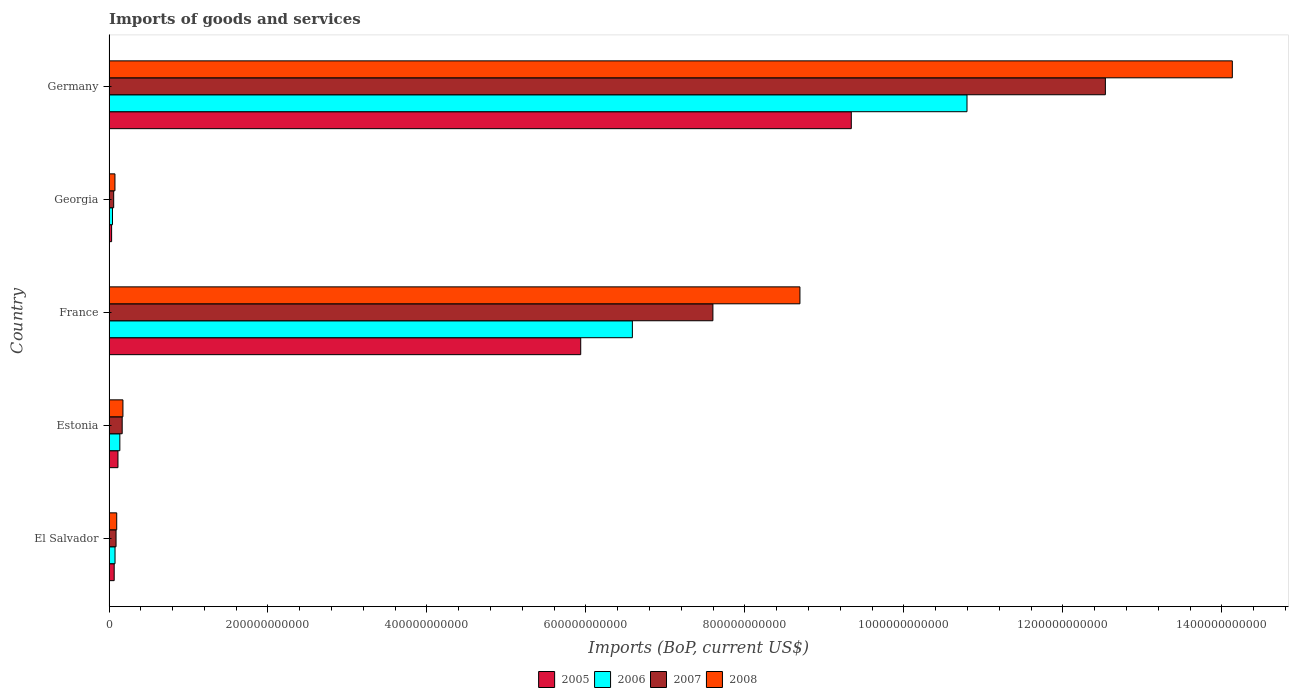How many different coloured bars are there?
Provide a succinct answer. 4. How many groups of bars are there?
Provide a short and direct response. 5. How many bars are there on the 4th tick from the top?
Offer a very short reply. 4. What is the label of the 4th group of bars from the top?
Offer a very short reply. Estonia. What is the amount spent on imports in 2005 in El Salvador?
Provide a short and direct response. 6.51e+09. Across all countries, what is the maximum amount spent on imports in 2008?
Offer a terse response. 1.41e+12. Across all countries, what is the minimum amount spent on imports in 2008?
Provide a succinct answer. 7.47e+09. In which country was the amount spent on imports in 2007 maximum?
Provide a short and direct response. Germany. In which country was the amount spent on imports in 2007 minimum?
Your answer should be compact. Georgia. What is the total amount spent on imports in 2006 in the graph?
Your answer should be compact. 1.76e+12. What is the difference between the amount spent on imports in 2007 in France and that in Germany?
Your answer should be very brief. -4.94e+11. What is the difference between the amount spent on imports in 2007 in Germany and the amount spent on imports in 2008 in Estonia?
Your answer should be compact. 1.24e+12. What is the average amount spent on imports in 2007 per country?
Your response must be concise. 4.09e+11. What is the difference between the amount spent on imports in 2008 and amount spent on imports in 2005 in Estonia?
Offer a terse response. 6.27e+09. In how many countries, is the amount spent on imports in 2006 greater than 360000000000 US$?
Give a very brief answer. 2. What is the ratio of the amount spent on imports in 2006 in El Salvador to that in Germany?
Give a very brief answer. 0.01. Is the amount spent on imports in 2008 in Georgia less than that in Germany?
Make the answer very short. Yes. Is the difference between the amount spent on imports in 2008 in El Salvador and Georgia greater than the difference between the amount spent on imports in 2005 in El Salvador and Georgia?
Provide a short and direct response. No. What is the difference between the highest and the second highest amount spent on imports in 2005?
Provide a succinct answer. 3.40e+11. What is the difference between the highest and the lowest amount spent on imports in 2007?
Give a very brief answer. 1.25e+12. Is the sum of the amount spent on imports in 2005 in El Salvador and Estonia greater than the maximum amount spent on imports in 2008 across all countries?
Give a very brief answer. No. Is it the case that in every country, the sum of the amount spent on imports in 2005 and amount spent on imports in 2007 is greater than the sum of amount spent on imports in 2008 and amount spent on imports in 2006?
Provide a succinct answer. No. Is it the case that in every country, the sum of the amount spent on imports in 2006 and amount spent on imports in 2005 is greater than the amount spent on imports in 2008?
Your answer should be compact. Yes. Are all the bars in the graph horizontal?
Make the answer very short. Yes. What is the difference between two consecutive major ticks on the X-axis?
Your answer should be compact. 2.00e+11. Does the graph contain any zero values?
Keep it short and to the point. No. How are the legend labels stacked?
Ensure brevity in your answer.  Horizontal. What is the title of the graph?
Give a very brief answer. Imports of goods and services. Does "1996" appear as one of the legend labels in the graph?
Your answer should be very brief. No. What is the label or title of the X-axis?
Make the answer very short. Imports (BoP, current US$). What is the label or title of the Y-axis?
Your response must be concise. Country. What is the Imports (BoP, current US$) in 2005 in El Salvador?
Keep it short and to the point. 6.51e+09. What is the Imports (BoP, current US$) in 2006 in El Salvador?
Offer a very short reply. 7.57e+09. What is the Imports (BoP, current US$) in 2007 in El Salvador?
Give a very brief answer. 8.86e+09. What is the Imports (BoP, current US$) of 2008 in El Salvador?
Your response must be concise. 9.70e+09. What is the Imports (BoP, current US$) in 2005 in Estonia?
Your response must be concise. 1.12e+1. What is the Imports (BoP, current US$) in 2006 in Estonia?
Make the answer very short. 1.36e+1. What is the Imports (BoP, current US$) of 2007 in Estonia?
Make the answer very short. 1.66e+1. What is the Imports (BoP, current US$) of 2008 in Estonia?
Provide a short and direct response. 1.75e+1. What is the Imports (BoP, current US$) of 2005 in France?
Provide a short and direct response. 5.93e+11. What is the Imports (BoP, current US$) of 2006 in France?
Your answer should be compact. 6.58e+11. What is the Imports (BoP, current US$) of 2007 in France?
Provide a succinct answer. 7.60e+11. What is the Imports (BoP, current US$) of 2008 in France?
Your answer should be compact. 8.69e+11. What is the Imports (BoP, current US$) in 2005 in Georgia?
Give a very brief answer. 3.27e+09. What is the Imports (BoP, current US$) in 2006 in Georgia?
Provide a succinct answer. 4.38e+09. What is the Imports (BoP, current US$) of 2007 in Georgia?
Make the answer very short. 5.88e+09. What is the Imports (BoP, current US$) of 2008 in Georgia?
Offer a very short reply. 7.47e+09. What is the Imports (BoP, current US$) of 2005 in Germany?
Ensure brevity in your answer.  9.34e+11. What is the Imports (BoP, current US$) in 2006 in Germany?
Provide a succinct answer. 1.08e+12. What is the Imports (BoP, current US$) in 2007 in Germany?
Keep it short and to the point. 1.25e+12. What is the Imports (BoP, current US$) of 2008 in Germany?
Give a very brief answer. 1.41e+12. Across all countries, what is the maximum Imports (BoP, current US$) of 2005?
Keep it short and to the point. 9.34e+11. Across all countries, what is the maximum Imports (BoP, current US$) of 2006?
Provide a succinct answer. 1.08e+12. Across all countries, what is the maximum Imports (BoP, current US$) in 2007?
Offer a terse response. 1.25e+12. Across all countries, what is the maximum Imports (BoP, current US$) in 2008?
Provide a succinct answer. 1.41e+12. Across all countries, what is the minimum Imports (BoP, current US$) in 2005?
Provide a short and direct response. 3.27e+09. Across all countries, what is the minimum Imports (BoP, current US$) in 2006?
Offer a terse response. 4.38e+09. Across all countries, what is the minimum Imports (BoP, current US$) in 2007?
Give a very brief answer. 5.88e+09. Across all countries, what is the minimum Imports (BoP, current US$) in 2008?
Ensure brevity in your answer.  7.47e+09. What is the total Imports (BoP, current US$) in 2005 in the graph?
Provide a succinct answer. 1.55e+12. What is the total Imports (BoP, current US$) in 2006 in the graph?
Offer a very short reply. 1.76e+12. What is the total Imports (BoP, current US$) in 2007 in the graph?
Make the answer very short. 2.04e+12. What is the total Imports (BoP, current US$) of 2008 in the graph?
Offer a very short reply. 2.32e+12. What is the difference between the Imports (BoP, current US$) of 2005 in El Salvador and that in Estonia?
Your answer should be very brief. -4.74e+09. What is the difference between the Imports (BoP, current US$) in 2006 in El Salvador and that in Estonia?
Make the answer very short. -6.05e+09. What is the difference between the Imports (BoP, current US$) of 2007 in El Salvador and that in Estonia?
Provide a short and direct response. -7.72e+09. What is the difference between the Imports (BoP, current US$) of 2008 in El Salvador and that in Estonia?
Your response must be concise. -7.81e+09. What is the difference between the Imports (BoP, current US$) of 2005 in El Salvador and that in France?
Keep it short and to the point. -5.87e+11. What is the difference between the Imports (BoP, current US$) of 2006 in El Salvador and that in France?
Your answer should be compact. -6.51e+11. What is the difference between the Imports (BoP, current US$) of 2007 in El Salvador and that in France?
Your answer should be compact. -7.51e+11. What is the difference between the Imports (BoP, current US$) of 2008 in El Salvador and that in France?
Offer a terse response. -8.60e+11. What is the difference between the Imports (BoP, current US$) of 2005 in El Salvador and that in Georgia?
Offer a terse response. 3.24e+09. What is the difference between the Imports (BoP, current US$) of 2006 in El Salvador and that in Georgia?
Your response must be concise. 3.19e+09. What is the difference between the Imports (BoP, current US$) of 2007 in El Salvador and that in Georgia?
Offer a terse response. 2.98e+09. What is the difference between the Imports (BoP, current US$) in 2008 in El Salvador and that in Georgia?
Your answer should be compact. 2.23e+09. What is the difference between the Imports (BoP, current US$) in 2005 in El Salvador and that in Germany?
Keep it short and to the point. -9.27e+11. What is the difference between the Imports (BoP, current US$) of 2006 in El Salvador and that in Germany?
Provide a succinct answer. -1.07e+12. What is the difference between the Imports (BoP, current US$) of 2007 in El Salvador and that in Germany?
Keep it short and to the point. -1.24e+12. What is the difference between the Imports (BoP, current US$) in 2008 in El Salvador and that in Germany?
Keep it short and to the point. -1.40e+12. What is the difference between the Imports (BoP, current US$) in 2005 in Estonia and that in France?
Your answer should be compact. -5.82e+11. What is the difference between the Imports (BoP, current US$) of 2006 in Estonia and that in France?
Ensure brevity in your answer.  -6.45e+11. What is the difference between the Imports (BoP, current US$) of 2007 in Estonia and that in France?
Make the answer very short. -7.43e+11. What is the difference between the Imports (BoP, current US$) in 2008 in Estonia and that in France?
Make the answer very short. -8.52e+11. What is the difference between the Imports (BoP, current US$) in 2005 in Estonia and that in Georgia?
Ensure brevity in your answer.  7.98e+09. What is the difference between the Imports (BoP, current US$) of 2006 in Estonia and that in Georgia?
Offer a very short reply. 9.24e+09. What is the difference between the Imports (BoP, current US$) of 2007 in Estonia and that in Georgia?
Offer a terse response. 1.07e+1. What is the difference between the Imports (BoP, current US$) in 2008 in Estonia and that in Georgia?
Your answer should be compact. 1.00e+1. What is the difference between the Imports (BoP, current US$) of 2005 in Estonia and that in Germany?
Keep it short and to the point. -9.23e+11. What is the difference between the Imports (BoP, current US$) of 2006 in Estonia and that in Germany?
Offer a terse response. -1.07e+12. What is the difference between the Imports (BoP, current US$) in 2007 in Estonia and that in Germany?
Provide a succinct answer. -1.24e+12. What is the difference between the Imports (BoP, current US$) of 2008 in Estonia and that in Germany?
Your response must be concise. -1.40e+12. What is the difference between the Imports (BoP, current US$) of 2005 in France and that in Georgia?
Make the answer very short. 5.90e+11. What is the difference between the Imports (BoP, current US$) in 2006 in France and that in Georgia?
Provide a short and direct response. 6.54e+11. What is the difference between the Imports (BoP, current US$) of 2007 in France and that in Georgia?
Keep it short and to the point. 7.54e+11. What is the difference between the Imports (BoP, current US$) of 2008 in France and that in Georgia?
Keep it short and to the point. 8.62e+11. What is the difference between the Imports (BoP, current US$) of 2005 in France and that in Germany?
Your answer should be compact. -3.40e+11. What is the difference between the Imports (BoP, current US$) of 2006 in France and that in Germany?
Give a very brief answer. -4.21e+11. What is the difference between the Imports (BoP, current US$) in 2007 in France and that in Germany?
Your answer should be compact. -4.94e+11. What is the difference between the Imports (BoP, current US$) in 2008 in France and that in Germany?
Make the answer very short. -5.44e+11. What is the difference between the Imports (BoP, current US$) of 2005 in Georgia and that in Germany?
Offer a very short reply. -9.31e+11. What is the difference between the Imports (BoP, current US$) of 2006 in Georgia and that in Germany?
Your answer should be compact. -1.08e+12. What is the difference between the Imports (BoP, current US$) of 2007 in Georgia and that in Germany?
Offer a terse response. -1.25e+12. What is the difference between the Imports (BoP, current US$) in 2008 in Georgia and that in Germany?
Provide a succinct answer. -1.41e+12. What is the difference between the Imports (BoP, current US$) of 2005 in El Salvador and the Imports (BoP, current US$) of 2006 in Estonia?
Your answer should be very brief. -7.11e+09. What is the difference between the Imports (BoP, current US$) of 2005 in El Salvador and the Imports (BoP, current US$) of 2007 in Estonia?
Make the answer very short. -1.01e+1. What is the difference between the Imports (BoP, current US$) in 2005 in El Salvador and the Imports (BoP, current US$) in 2008 in Estonia?
Your answer should be compact. -1.10e+1. What is the difference between the Imports (BoP, current US$) of 2006 in El Salvador and the Imports (BoP, current US$) of 2007 in Estonia?
Give a very brief answer. -9.00e+09. What is the difference between the Imports (BoP, current US$) of 2006 in El Salvador and the Imports (BoP, current US$) of 2008 in Estonia?
Your answer should be compact. -9.94e+09. What is the difference between the Imports (BoP, current US$) of 2007 in El Salvador and the Imports (BoP, current US$) of 2008 in Estonia?
Offer a very short reply. -8.66e+09. What is the difference between the Imports (BoP, current US$) in 2005 in El Salvador and the Imports (BoP, current US$) in 2006 in France?
Your answer should be compact. -6.52e+11. What is the difference between the Imports (BoP, current US$) in 2005 in El Salvador and the Imports (BoP, current US$) in 2007 in France?
Your answer should be very brief. -7.53e+11. What is the difference between the Imports (BoP, current US$) of 2005 in El Salvador and the Imports (BoP, current US$) of 2008 in France?
Ensure brevity in your answer.  -8.63e+11. What is the difference between the Imports (BoP, current US$) of 2006 in El Salvador and the Imports (BoP, current US$) of 2007 in France?
Provide a short and direct response. -7.52e+11. What is the difference between the Imports (BoP, current US$) in 2006 in El Salvador and the Imports (BoP, current US$) in 2008 in France?
Your response must be concise. -8.62e+11. What is the difference between the Imports (BoP, current US$) of 2007 in El Salvador and the Imports (BoP, current US$) of 2008 in France?
Your answer should be very brief. -8.60e+11. What is the difference between the Imports (BoP, current US$) of 2005 in El Salvador and the Imports (BoP, current US$) of 2006 in Georgia?
Ensure brevity in your answer.  2.13e+09. What is the difference between the Imports (BoP, current US$) of 2005 in El Salvador and the Imports (BoP, current US$) of 2007 in Georgia?
Provide a short and direct response. 6.29e+08. What is the difference between the Imports (BoP, current US$) in 2005 in El Salvador and the Imports (BoP, current US$) in 2008 in Georgia?
Provide a succinct answer. -9.62e+08. What is the difference between the Imports (BoP, current US$) in 2006 in El Salvador and the Imports (BoP, current US$) in 2007 in Georgia?
Provide a succinct answer. 1.69e+09. What is the difference between the Imports (BoP, current US$) of 2006 in El Salvador and the Imports (BoP, current US$) of 2008 in Georgia?
Keep it short and to the point. 1.00e+08. What is the difference between the Imports (BoP, current US$) in 2007 in El Salvador and the Imports (BoP, current US$) in 2008 in Georgia?
Offer a very short reply. 1.38e+09. What is the difference between the Imports (BoP, current US$) of 2005 in El Salvador and the Imports (BoP, current US$) of 2006 in Germany?
Provide a succinct answer. -1.07e+12. What is the difference between the Imports (BoP, current US$) of 2005 in El Salvador and the Imports (BoP, current US$) of 2007 in Germany?
Your answer should be very brief. -1.25e+12. What is the difference between the Imports (BoP, current US$) of 2005 in El Salvador and the Imports (BoP, current US$) of 2008 in Germany?
Provide a short and direct response. -1.41e+12. What is the difference between the Imports (BoP, current US$) of 2006 in El Salvador and the Imports (BoP, current US$) of 2007 in Germany?
Your answer should be very brief. -1.25e+12. What is the difference between the Imports (BoP, current US$) in 2006 in El Salvador and the Imports (BoP, current US$) in 2008 in Germany?
Make the answer very short. -1.41e+12. What is the difference between the Imports (BoP, current US$) in 2007 in El Salvador and the Imports (BoP, current US$) in 2008 in Germany?
Offer a terse response. -1.40e+12. What is the difference between the Imports (BoP, current US$) of 2005 in Estonia and the Imports (BoP, current US$) of 2006 in France?
Ensure brevity in your answer.  -6.47e+11. What is the difference between the Imports (BoP, current US$) of 2005 in Estonia and the Imports (BoP, current US$) of 2007 in France?
Your response must be concise. -7.48e+11. What is the difference between the Imports (BoP, current US$) of 2005 in Estonia and the Imports (BoP, current US$) of 2008 in France?
Make the answer very short. -8.58e+11. What is the difference between the Imports (BoP, current US$) of 2006 in Estonia and the Imports (BoP, current US$) of 2007 in France?
Ensure brevity in your answer.  -7.46e+11. What is the difference between the Imports (BoP, current US$) in 2006 in Estonia and the Imports (BoP, current US$) in 2008 in France?
Offer a very short reply. -8.56e+11. What is the difference between the Imports (BoP, current US$) in 2007 in Estonia and the Imports (BoP, current US$) in 2008 in France?
Your answer should be very brief. -8.53e+11. What is the difference between the Imports (BoP, current US$) of 2005 in Estonia and the Imports (BoP, current US$) of 2006 in Georgia?
Offer a terse response. 6.87e+09. What is the difference between the Imports (BoP, current US$) in 2005 in Estonia and the Imports (BoP, current US$) in 2007 in Georgia?
Keep it short and to the point. 5.37e+09. What is the difference between the Imports (BoP, current US$) of 2005 in Estonia and the Imports (BoP, current US$) of 2008 in Georgia?
Offer a terse response. 3.78e+09. What is the difference between the Imports (BoP, current US$) of 2006 in Estonia and the Imports (BoP, current US$) of 2007 in Georgia?
Give a very brief answer. 7.74e+09. What is the difference between the Imports (BoP, current US$) in 2006 in Estonia and the Imports (BoP, current US$) in 2008 in Georgia?
Ensure brevity in your answer.  6.15e+09. What is the difference between the Imports (BoP, current US$) in 2007 in Estonia and the Imports (BoP, current US$) in 2008 in Georgia?
Ensure brevity in your answer.  9.10e+09. What is the difference between the Imports (BoP, current US$) of 2005 in Estonia and the Imports (BoP, current US$) of 2006 in Germany?
Provide a succinct answer. -1.07e+12. What is the difference between the Imports (BoP, current US$) of 2005 in Estonia and the Imports (BoP, current US$) of 2007 in Germany?
Offer a terse response. -1.24e+12. What is the difference between the Imports (BoP, current US$) of 2005 in Estonia and the Imports (BoP, current US$) of 2008 in Germany?
Give a very brief answer. -1.40e+12. What is the difference between the Imports (BoP, current US$) in 2006 in Estonia and the Imports (BoP, current US$) in 2007 in Germany?
Your answer should be very brief. -1.24e+12. What is the difference between the Imports (BoP, current US$) of 2006 in Estonia and the Imports (BoP, current US$) of 2008 in Germany?
Your response must be concise. -1.40e+12. What is the difference between the Imports (BoP, current US$) of 2007 in Estonia and the Imports (BoP, current US$) of 2008 in Germany?
Ensure brevity in your answer.  -1.40e+12. What is the difference between the Imports (BoP, current US$) in 2005 in France and the Imports (BoP, current US$) in 2006 in Georgia?
Give a very brief answer. 5.89e+11. What is the difference between the Imports (BoP, current US$) of 2005 in France and the Imports (BoP, current US$) of 2007 in Georgia?
Ensure brevity in your answer.  5.88e+11. What is the difference between the Imports (BoP, current US$) in 2005 in France and the Imports (BoP, current US$) in 2008 in Georgia?
Ensure brevity in your answer.  5.86e+11. What is the difference between the Imports (BoP, current US$) in 2006 in France and the Imports (BoP, current US$) in 2007 in Georgia?
Your answer should be compact. 6.53e+11. What is the difference between the Imports (BoP, current US$) of 2006 in France and the Imports (BoP, current US$) of 2008 in Georgia?
Your response must be concise. 6.51e+11. What is the difference between the Imports (BoP, current US$) of 2007 in France and the Imports (BoP, current US$) of 2008 in Georgia?
Your response must be concise. 7.52e+11. What is the difference between the Imports (BoP, current US$) of 2005 in France and the Imports (BoP, current US$) of 2006 in Germany?
Keep it short and to the point. -4.86e+11. What is the difference between the Imports (BoP, current US$) of 2005 in France and the Imports (BoP, current US$) of 2007 in Germany?
Provide a succinct answer. -6.60e+11. What is the difference between the Imports (BoP, current US$) in 2005 in France and the Imports (BoP, current US$) in 2008 in Germany?
Provide a short and direct response. -8.20e+11. What is the difference between the Imports (BoP, current US$) in 2006 in France and the Imports (BoP, current US$) in 2007 in Germany?
Your answer should be compact. -5.95e+11. What is the difference between the Imports (BoP, current US$) in 2006 in France and the Imports (BoP, current US$) in 2008 in Germany?
Your response must be concise. -7.55e+11. What is the difference between the Imports (BoP, current US$) of 2007 in France and the Imports (BoP, current US$) of 2008 in Germany?
Your answer should be very brief. -6.53e+11. What is the difference between the Imports (BoP, current US$) in 2005 in Georgia and the Imports (BoP, current US$) in 2006 in Germany?
Make the answer very short. -1.08e+12. What is the difference between the Imports (BoP, current US$) of 2005 in Georgia and the Imports (BoP, current US$) of 2007 in Germany?
Offer a very short reply. -1.25e+12. What is the difference between the Imports (BoP, current US$) in 2005 in Georgia and the Imports (BoP, current US$) in 2008 in Germany?
Provide a short and direct response. -1.41e+12. What is the difference between the Imports (BoP, current US$) in 2006 in Georgia and the Imports (BoP, current US$) in 2007 in Germany?
Your response must be concise. -1.25e+12. What is the difference between the Imports (BoP, current US$) in 2006 in Georgia and the Imports (BoP, current US$) in 2008 in Germany?
Provide a short and direct response. -1.41e+12. What is the difference between the Imports (BoP, current US$) of 2007 in Georgia and the Imports (BoP, current US$) of 2008 in Germany?
Your answer should be very brief. -1.41e+12. What is the average Imports (BoP, current US$) of 2005 per country?
Your response must be concise. 3.10e+11. What is the average Imports (BoP, current US$) in 2006 per country?
Offer a terse response. 3.53e+11. What is the average Imports (BoP, current US$) of 2007 per country?
Provide a short and direct response. 4.09e+11. What is the average Imports (BoP, current US$) of 2008 per country?
Keep it short and to the point. 4.63e+11. What is the difference between the Imports (BoP, current US$) of 2005 and Imports (BoP, current US$) of 2006 in El Salvador?
Your answer should be compact. -1.06e+09. What is the difference between the Imports (BoP, current US$) of 2005 and Imports (BoP, current US$) of 2007 in El Salvador?
Provide a succinct answer. -2.35e+09. What is the difference between the Imports (BoP, current US$) in 2005 and Imports (BoP, current US$) in 2008 in El Salvador?
Your answer should be very brief. -3.19e+09. What is the difference between the Imports (BoP, current US$) in 2006 and Imports (BoP, current US$) in 2007 in El Salvador?
Keep it short and to the point. -1.28e+09. What is the difference between the Imports (BoP, current US$) in 2006 and Imports (BoP, current US$) in 2008 in El Salvador?
Provide a short and direct response. -2.13e+09. What is the difference between the Imports (BoP, current US$) in 2007 and Imports (BoP, current US$) in 2008 in El Salvador?
Provide a short and direct response. -8.44e+08. What is the difference between the Imports (BoP, current US$) of 2005 and Imports (BoP, current US$) of 2006 in Estonia?
Your response must be concise. -2.37e+09. What is the difference between the Imports (BoP, current US$) of 2005 and Imports (BoP, current US$) of 2007 in Estonia?
Your response must be concise. -5.32e+09. What is the difference between the Imports (BoP, current US$) of 2005 and Imports (BoP, current US$) of 2008 in Estonia?
Make the answer very short. -6.27e+09. What is the difference between the Imports (BoP, current US$) in 2006 and Imports (BoP, current US$) in 2007 in Estonia?
Ensure brevity in your answer.  -2.95e+09. What is the difference between the Imports (BoP, current US$) in 2006 and Imports (BoP, current US$) in 2008 in Estonia?
Offer a terse response. -3.90e+09. What is the difference between the Imports (BoP, current US$) in 2007 and Imports (BoP, current US$) in 2008 in Estonia?
Your answer should be compact. -9.43e+08. What is the difference between the Imports (BoP, current US$) in 2005 and Imports (BoP, current US$) in 2006 in France?
Provide a short and direct response. -6.50e+1. What is the difference between the Imports (BoP, current US$) of 2005 and Imports (BoP, current US$) of 2007 in France?
Provide a short and direct response. -1.66e+11. What is the difference between the Imports (BoP, current US$) of 2005 and Imports (BoP, current US$) of 2008 in France?
Offer a terse response. -2.76e+11. What is the difference between the Imports (BoP, current US$) in 2006 and Imports (BoP, current US$) in 2007 in France?
Offer a very short reply. -1.01e+11. What is the difference between the Imports (BoP, current US$) of 2006 and Imports (BoP, current US$) of 2008 in France?
Provide a succinct answer. -2.11e+11. What is the difference between the Imports (BoP, current US$) in 2007 and Imports (BoP, current US$) in 2008 in France?
Your answer should be compact. -1.09e+11. What is the difference between the Imports (BoP, current US$) of 2005 and Imports (BoP, current US$) of 2006 in Georgia?
Give a very brief answer. -1.11e+09. What is the difference between the Imports (BoP, current US$) of 2005 and Imports (BoP, current US$) of 2007 in Georgia?
Your answer should be very brief. -2.61e+09. What is the difference between the Imports (BoP, current US$) of 2005 and Imports (BoP, current US$) of 2008 in Georgia?
Make the answer very short. -4.20e+09. What is the difference between the Imports (BoP, current US$) of 2006 and Imports (BoP, current US$) of 2007 in Georgia?
Your answer should be very brief. -1.50e+09. What is the difference between the Imports (BoP, current US$) of 2006 and Imports (BoP, current US$) of 2008 in Georgia?
Your response must be concise. -3.09e+09. What is the difference between the Imports (BoP, current US$) of 2007 and Imports (BoP, current US$) of 2008 in Georgia?
Ensure brevity in your answer.  -1.59e+09. What is the difference between the Imports (BoP, current US$) of 2005 and Imports (BoP, current US$) of 2006 in Germany?
Keep it short and to the point. -1.46e+11. What is the difference between the Imports (BoP, current US$) in 2005 and Imports (BoP, current US$) in 2007 in Germany?
Provide a succinct answer. -3.20e+11. What is the difference between the Imports (BoP, current US$) of 2005 and Imports (BoP, current US$) of 2008 in Germany?
Your response must be concise. -4.79e+11. What is the difference between the Imports (BoP, current US$) of 2006 and Imports (BoP, current US$) of 2007 in Germany?
Offer a very short reply. -1.74e+11. What is the difference between the Imports (BoP, current US$) in 2006 and Imports (BoP, current US$) in 2008 in Germany?
Keep it short and to the point. -3.34e+11. What is the difference between the Imports (BoP, current US$) of 2007 and Imports (BoP, current US$) of 2008 in Germany?
Offer a terse response. -1.60e+11. What is the ratio of the Imports (BoP, current US$) in 2005 in El Salvador to that in Estonia?
Provide a succinct answer. 0.58. What is the ratio of the Imports (BoP, current US$) of 2006 in El Salvador to that in Estonia?
Your response must be concise. 0.56. What is the ratio of the Imports (BoP, current US$) in 2007 in El Salvador to that in Estonia?
Ensure brevity in your answer.  0.53. What is the ratio of the Imports (BoP, current US$) of 2008 in El Salvador to that in Estonia?
Provide a short and direct response. 0.55. What is the ratio of the Imports (BoP, current US$) of 2005 in El Salvador to that in France?
Provide a short and direct response. 0.01. What is the ratio of the Imports (BoP, current US$) of 2006 in El Salvador to that in France?
Offer a terse response. 0.01. What is the ratio of the Imports (BoP, current US$) of 2007 in El Salvador to that in France?
Provide a short and direct response. 0.01. What is the ratio of the Imports (BoP, current US$) of 2008 in El Salvador to that in France?
Offer a very short reply. 0.01. What is the ratio of the Imports (BoP, current US$) in 2005 in El Salvador to that in Georgia?
Give a very brief answer. 1.99. What is the ratio of the Imports (BoP, current US$) in 2006 in El Salvador to that in Georgia?
Your answer should be very brief. 1.73. What is the ratio of the Imports (BoP, current US$) of 2007 in El Salvador to that in Georgia?
Ensure brevity in your answer.  1.51. What is the ratio of the Imports (BoP, current US$) in 2008 in El Salvador to that in Georgia?
Give a very brief answer. 1.3. What is the ratio of the Imports (BoP, current US$) of 2005 in El Salvador to that in Germany?
Your response must be concise. 0.01. What is the ratio of the Imports (BoP, current US$) of 2006 in El Salvador to that in Germany?
Keep it short and to the point. 0.01. What is the ratio of the Imports (BoP, current US$) of 2007 in El Salvador to that in Germany?
Your answer should be compact. 0.01. What is the ratio of the Imports (BoP, current US$) in 2008 in El Salvador to that in Germany?
Provide a succinct answer. 0.01. What is the ratio of the Imports (BoP, current US$) in 2005 in Estonia to that in France?
Ensure brevity in your answer.  0.02. What is the ratio of the Imports (BoP, current US$) of 2006 in Estonia to that in France?
Offer a terse response. 0.02. What is the ratio of the Imports (BoP, current US$) of 2007 in Estonia to that in France?
Provide a short and direct response. 0.02. What is the ratio of the Imports (BoP, current US$) of 2008 in Estonia to that in France?
Ensure brevity in your answer.  0.02. What is the ratio of the Imports (BoP, current US$) in 2005 in Estonia to that in Georgia?
Your response must be concise. 3.44. What is the ratio of the Imports (BoP, current US$) of 2006 in Estonia to that in Georgia?
Ensure brevity in your answer.  3.11. What is the ratio of the Imports (BoP, current US$) in 2007 in Estonia to that in Georgia?
Ensure brevity in your answer.  2.82. What is the ratio of the Imports (BoP, current US$) of 2008 in Estonia to that in Georgia?
Provide a succinct answer. 2.34. What is the ratio of the Imports (BoP, current US$) in 2005 in Estonia to that in Germany?
Ensure brevity in your answer.  0.01. What is the ratio of the Imports (BoP, current US$) of 2006 in Estonia to that in Germany?
Give a very brief answer. 0.01. What is the ratio of the Imports (BoP, current US$) in 2007 in Estonia to that in Germany?
Your response must be concise. 0.01. What is the ratio of the Imports (BoP, current US$) of 2008 in Estonia to that in Germany?
Make the answer very short. 0.01. What is the ratio of the Imports (BoP, current US$) in 2005 in France to that in Georgia?
Keep it short and to the point. 181.64. What is the ratio of the Imports (BoP, current US$) in 2006 in France to that in Georgia?
Provide a short and direct response. 150.45. What is the ratio of the Imports (BoP, current US$) of 2007 in France to that in Georgia?
Ensure brevity in your answer.  129.23. What is the ratio of the Imports (BoP, current US$) in 2008 in France to that in Georgia?
Your answer should be compact. 116.35. What is the ratio of the Imports (BoP, current US$) of 2005 in France to that in Germany?
Your answer should be compact. 0.64. What is the ratio of the Imports (BoP, current US$) in 2006 in France to that in Germany?
Your answer should be compact. 0.61. What is the ratio of the Imports (BoP, current US$) of 2007 in France to that in Germany?
Provide a succinct answer. 0.61. What is the ratio of the Imports (BoP, current US$) of 2008 in France to that in Germany?
Your answer should be very brief. 0.62. What is the ratio of the Imports (BoP, current US$) of 2005 in Georgia to that in Germany?
Make the answer very short. 0. What is the ratio of the Imports (BoP, current US$) in 2006 in Georgia to that in Germany?
Give a very brief answer. 0. What is the ratio of the Imports (BoP, current US$) of 2007 in Georgia to that in Germany?
Keep it short and to the point. 0. What is the ratio of the Imports (BoP, current US$) of 2008 in Georgia to that in Germany?
Make the answer very short. 0.01. What is the difference between the highest and the second highest Imports (BoP, current US$) of 2005?
Your answer should be very brief. 3.40e+11. What is the difference between the highest and the second highest Imports (BoP, current US$) in 2006?
Offer a terse response. 4.21e+11. What is the difference between the highest and the second highest Imports (BoP, current US$) in 2007?
Keep it short and to the point. 4.94e+11. What is the difference between the highest and the second highest Imports (BoP, current US$) of 2008?
Ensure brevity in your answer.  5.44e+11. What is the difference between the highest and the lowest Imports (BoP, current US$) in 2005?
Give a very brief answer. 9.31e+11. What is the difference between the highest and the lowest Imports (BoP, current US$) of 2006?
Make the answer very short. 1.08e+12. What is the difference between the highest and the lowest Imports (BoP, current US$) of 2007?
Ensure brevity in your answer.  1.25e+12. What is the difference between the highest and the lowest Imports (BoP, current US$) in 2008?
Offer a terse response. 1.41e+12. 